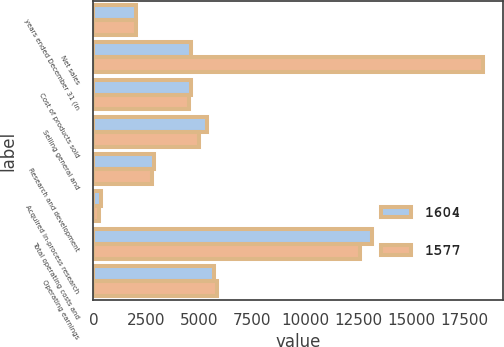Convert chart to OTSL. <chart><loc_0><loc_0><loc_500><loc_500><stacked_bar_chart><ecel><fcel>years ended December 31 (in<fcel>Net sales<fcel>Cost of products sold<fcel>Selling general and<fcel>Research and development<fcel>Acquired in-process research<fcel>Total operating costs and<fcel>Operating earnings<nl><fcel>1604<fcel>2013<fcel>4581<fcel>4581<fcel>5352<fcel>2855<fcel>338<fcel>13126<fcel>5664<nl><fcel>1577<fcel>2012<fcel>18380<fcel>4508<fcel>4989<fcel>2778<fcel>288<fcel>12563<fcel>5817<nl></chart> 